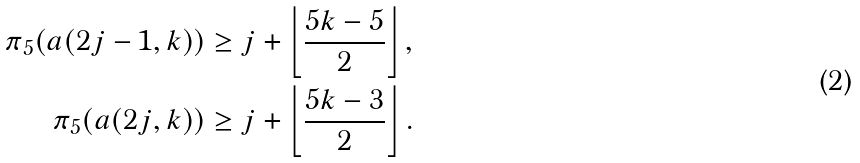Convert formula to latex. <formula><loc_0><loc_0><loc_500><loc_500>\pi _ { 5 } ( a ( 2 j - 1 , k ) ) & \geq j + \left \lfloor \frac { 5 k - 5 } { 2 } \right \rfloor , \\ \pi _ { 5 } ( a ( 2 j , k ) ) & \geq j + \left \lfloor \frac { 5 k - 3 } { 2 } \right \rfloor .</formula> 